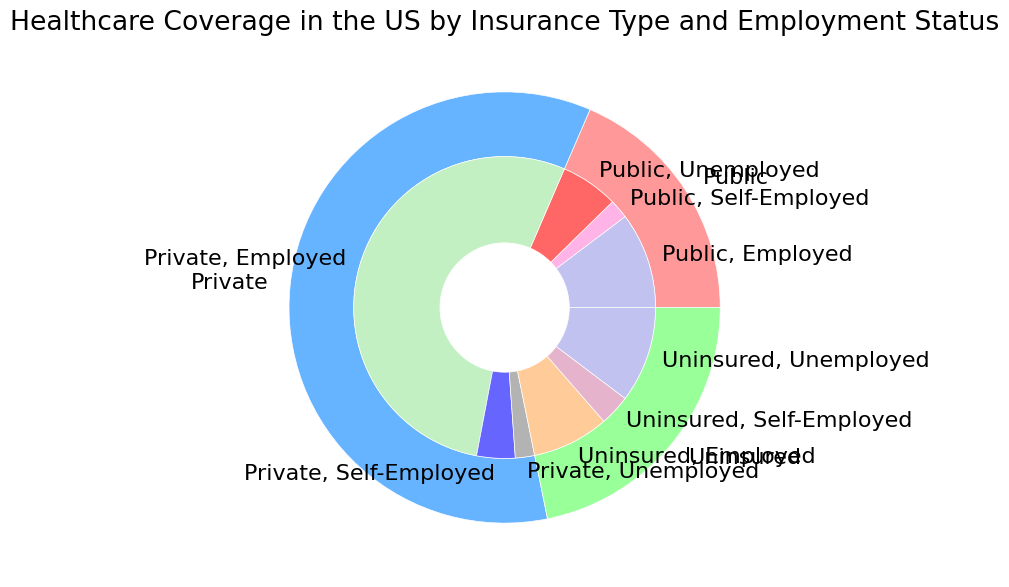How many people are covered by private insurance but are unemployed? To find this, look at the inner part of the pie chart where it shows private insurance coverage and locate the segment for the unemployed. The chart indicates there are 5,000,000 people in this category.
Answer: 5,000,000 Which group has the highest number of uninsured individuals? In the inner pie chart, identify the segments corresponding to uninsured individuals and compare the amounts associated with employed, self-employed, and unemployed categories. The largest value is for uninsured and unemployed, which totals 25,000,000 people.
Answer: Unemployed What is the total number of people with public insurance coverage? Sum the numbers for public insurance coverage: Employed (25,000,000), Self-Employed (5,000,000), and Unemployed (15,000,000). 25,000,000 + 5,000,000 + 15,000,000 = 45,000,000.
Answer: 45,000,000 How does the size of the population with private insurance and employed compare to the size of the population with public insurance and employed? Compare the segments showing private insurance for employed (130,000,000) and public insurance for employed (25,000,000). 130,000,000 is significantly larger than 25,000,000.
Answer: Private insurance and employed have a significantly larger population What slices are colored red and what do they represent? The shades of red are used in the inner part of the pie chart. The slices colored red represent different employment statuses under uninsured coverage: employed, self-employed, and unemployed.
Answer: Uninsured categories What is the difference in the total population between those covered by public insurance and those uninsured? Calculate the totals for public insurance (45,000,000) and uninsured (20,000,000 + 8,000,000 + 25,000,000 = 53,000,000), then find the difference: 53,000,000 - 45,000,000 = 8,000,000.
Answer: 8,000,000 What percentage of the total population having insurance is covered by private insurance? Sum the total populations: Public (45,000,000), Private (130,000,000 + 10,000,000 + 5,000,000 = 145,000,000), Uninsured (53,000,000). The percentage is (145,000,000 / (45,000,000 + 145,000,000 + 53,000,000)) * 100.
Answer: Approximately 59.5% How many more people are employed with private insurance compared to those self-employed with public insurance? Compare the employed with private insurance (130,000,000) to the self-employed with public insurance (5,000,000). Find the difference: 130,000,000 - 5,000,000 = 125,000,000.
Answer: 125,000,000 Identify the smallest group in terms of healthcare coverage type and employment status. Look at the inner pie chart and find the smallest segment. The smallest group is public insurance for self-employed, totaling 5,000,000 people.
Answer: Public, Self-Employed 